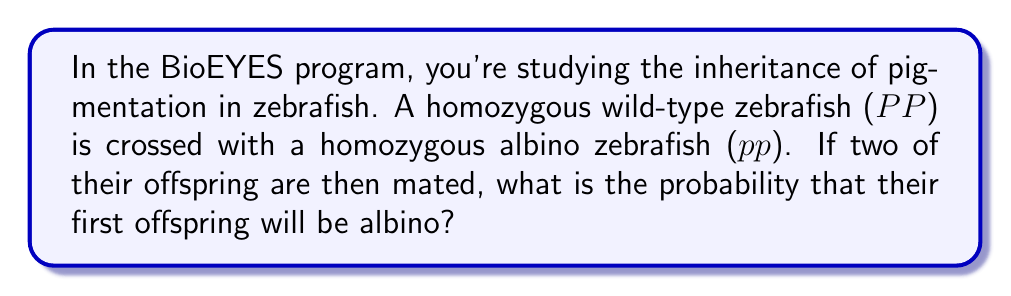What is the answer to this math problem? Let's approach this step-by-step:

1) First, we need to determine the genotype of the F1 generation (the offspring of the original cross).
   - P1 generation: PP (wild-type) × pp (albino)
   - F1 generation: All offspring will be Pp (heterozygous)

2) Now, we're crossing two F1 individuals: Pp × Pp

3) To determine the possible genotypes of their offspring, we can use a Punnett square:

   $$
   \begin{array}{c|cc}
    & P & p \\
   \hline
   P & PP & Pp \\
   p & Pp & pp \\
   \end{array}
   $$

4) From the Punnett square, we can see the possible outcomes:
   - PP (wild-type): 1/4
   - Pp (wild-type): 2/4 = 1/2
   - pp (albino): 1/4

5) The question asks for the probability of the first offspring being albino. This corresponds to the pp genotype.

6) The probability of pp occurring is 1/4 or 0.25 or 25%.
Answer: $\frac{1}{4}$ or 0.25 or 25% 